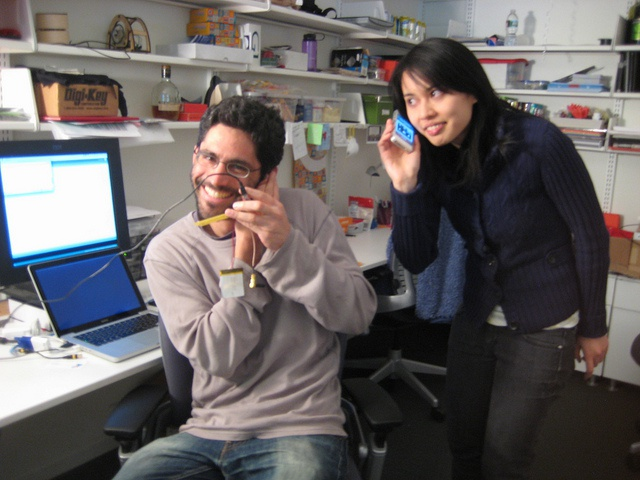Describe the objects in this image and their specific colors. I can see people in black, brown, tan, and gray tones, people in black, gray, and darkgray tones, tv in black, white, navy, and lightblue tones, chair in black, gray, and darkgray tones, and laptop in black, darkblue, navy, and darkgray tones in this image. 